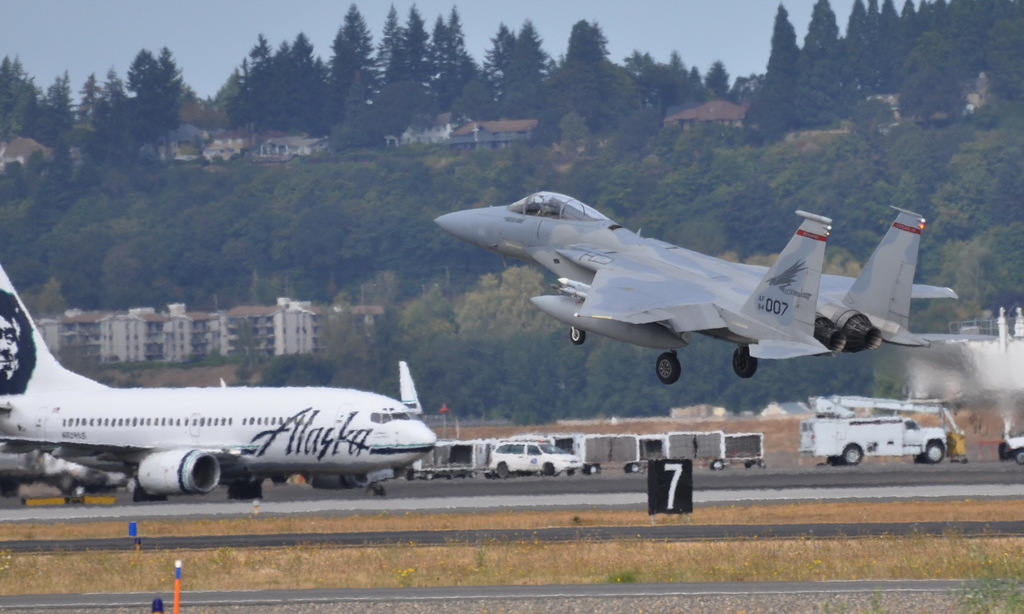What activities could be inferred happening around this scene concerning both military and civil aviation? This scene likely involves a demonstration of military prowess or readiness during an airshow or military exercise, and the presence of the commercial airplane suggests it might be parked due to those events or providing a stark contrast to illustrate the diverse capabilities of different types of aircraft. What impact do events like airshows have on local communities? Airshows can boost local tourism and economy, bring communities together, and increase interest and recruitment in aviation-related fields. However, they can also lead to temporary noise disturbances. 